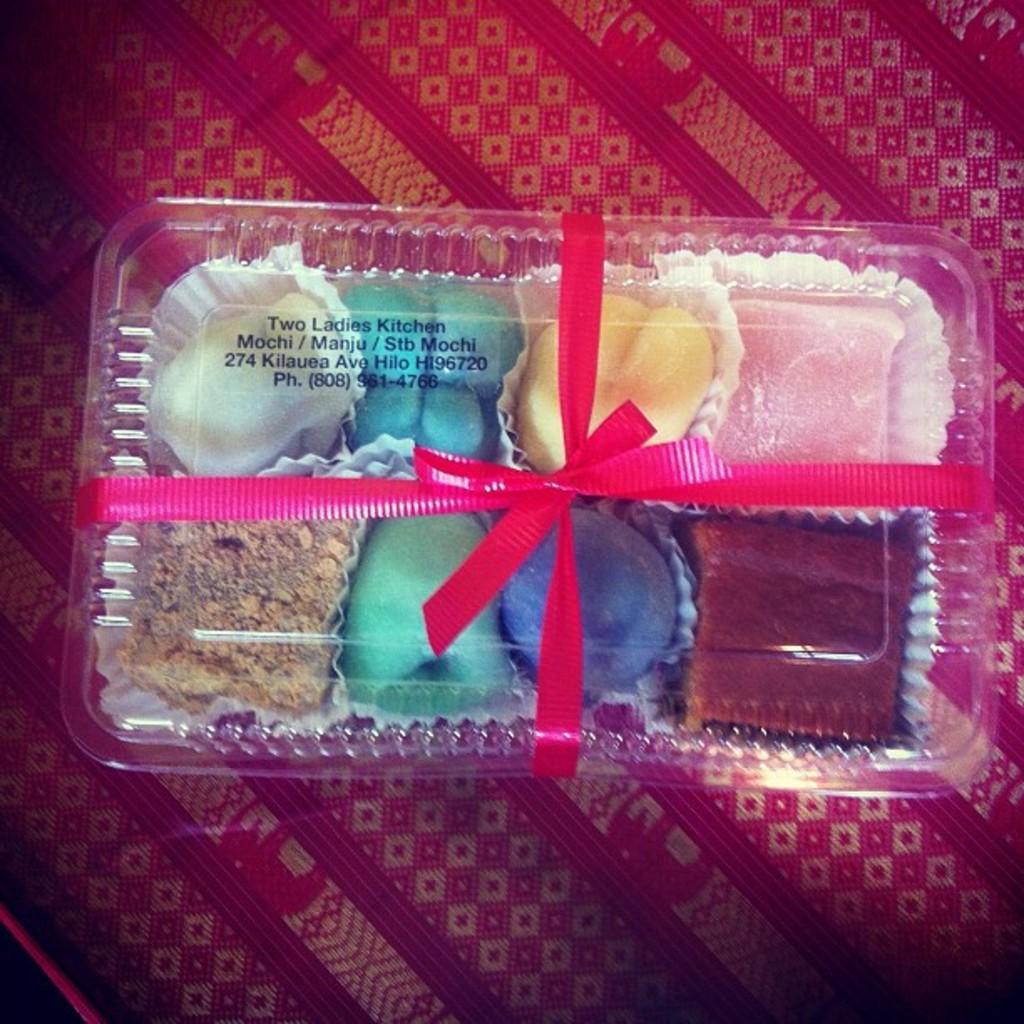Describe this image in one or two sentences. In the image in the center, we can see one table. On the table, we can see one cloth and one plastic box. And we can see one pink ribbon tied to the box. In the box, we can see some food items. 